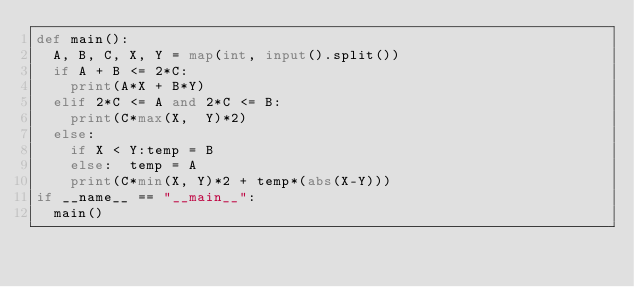<code> <loc_0><loc_0><loc_500><loc_500><_Python_>def main():
  A, B, C, X, Y = map(int, input().split())
  if A + B <= 2*C:
    print(A*X + B*Y)
  elif 2*C <= A and 2*C <= B:
    print(C*max(X,  Y)*2)
  else:
    if X < Y:temp = B
    else:  temp = A
    print(C*min(X, Y)*2 + temp*(abs(X-Y)))
if __name__ == "__main__":
  main()</code> 